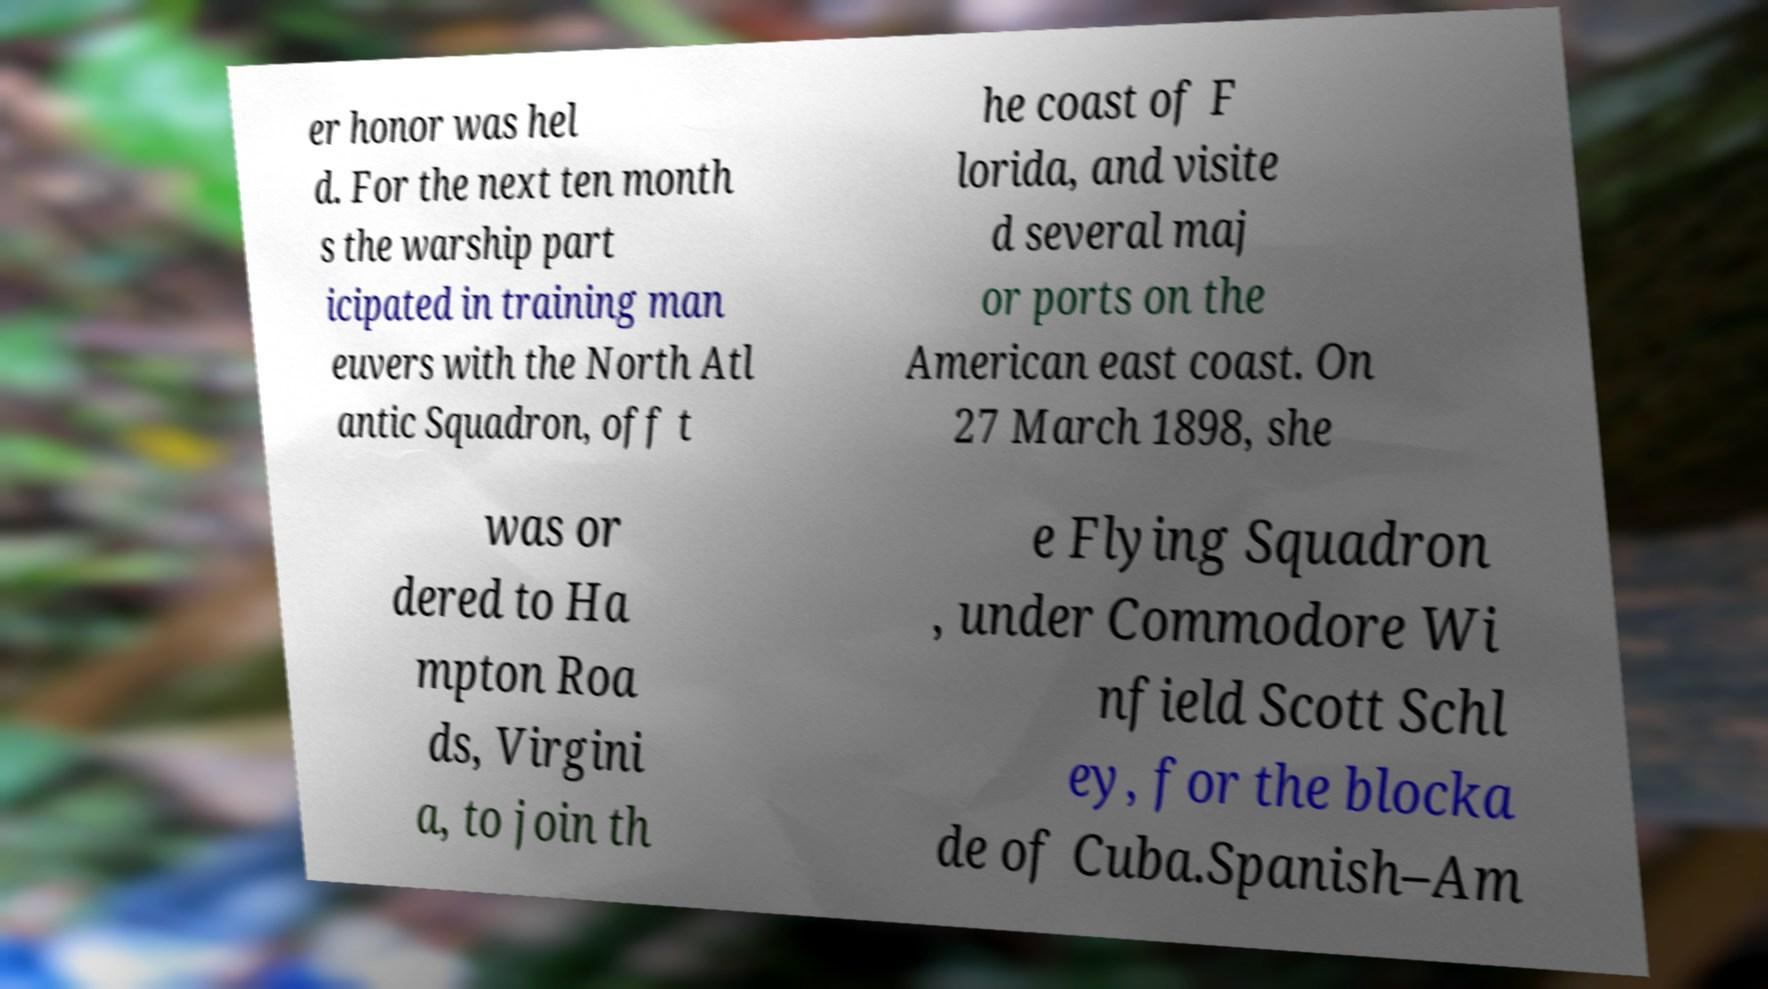Can you accurately transcribe the text from the provided image for me? er honor was hel d. For the next ten month s the warship part icipated in training man euvers with the North Atl antic Squadron, off t he coast of F lorida, and visite d several maj or ports on the American east coast. On 27 March 1898, she was or dered to Ha mpton Roa ds, Virgini a, to join th e Flying Squadron , under Commodore Wi nfield Scott Schl ey, for the blocka de of Cuba.Spanish–Am 